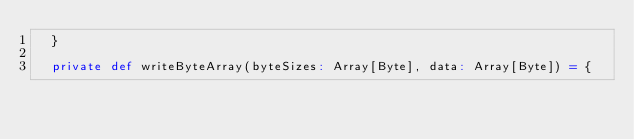Convert code to text. <code><loc_0><loc_0><loc_500><loc_500><_Scala_>  }

  private def writeByteArray(byteSizes: Array[Byte], data: Array[Byte]) = {</code> 